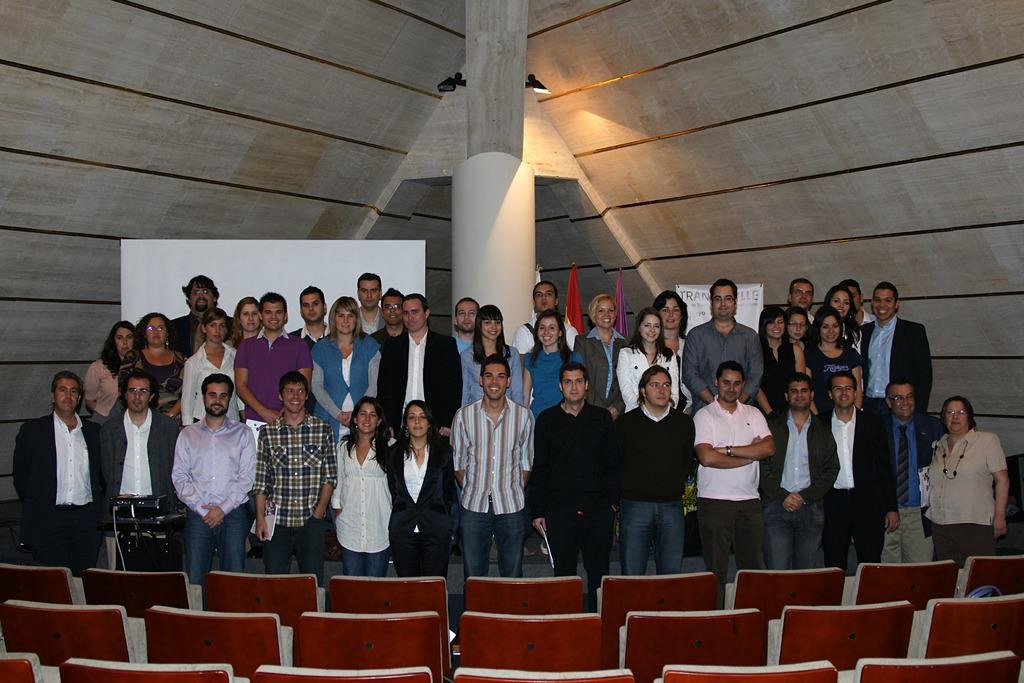How many individuals are present in the image? There are a lot of people in the image. What are the people in the image doing? The people are standing. What type of flag is being balanced on the people's heads in the image? There is no flag or balancing act present in the image; the people are simply standing. What kind of apparel are the people wearing in the image? The provided facts do not mention any specific apparel worn by the people in the image. 